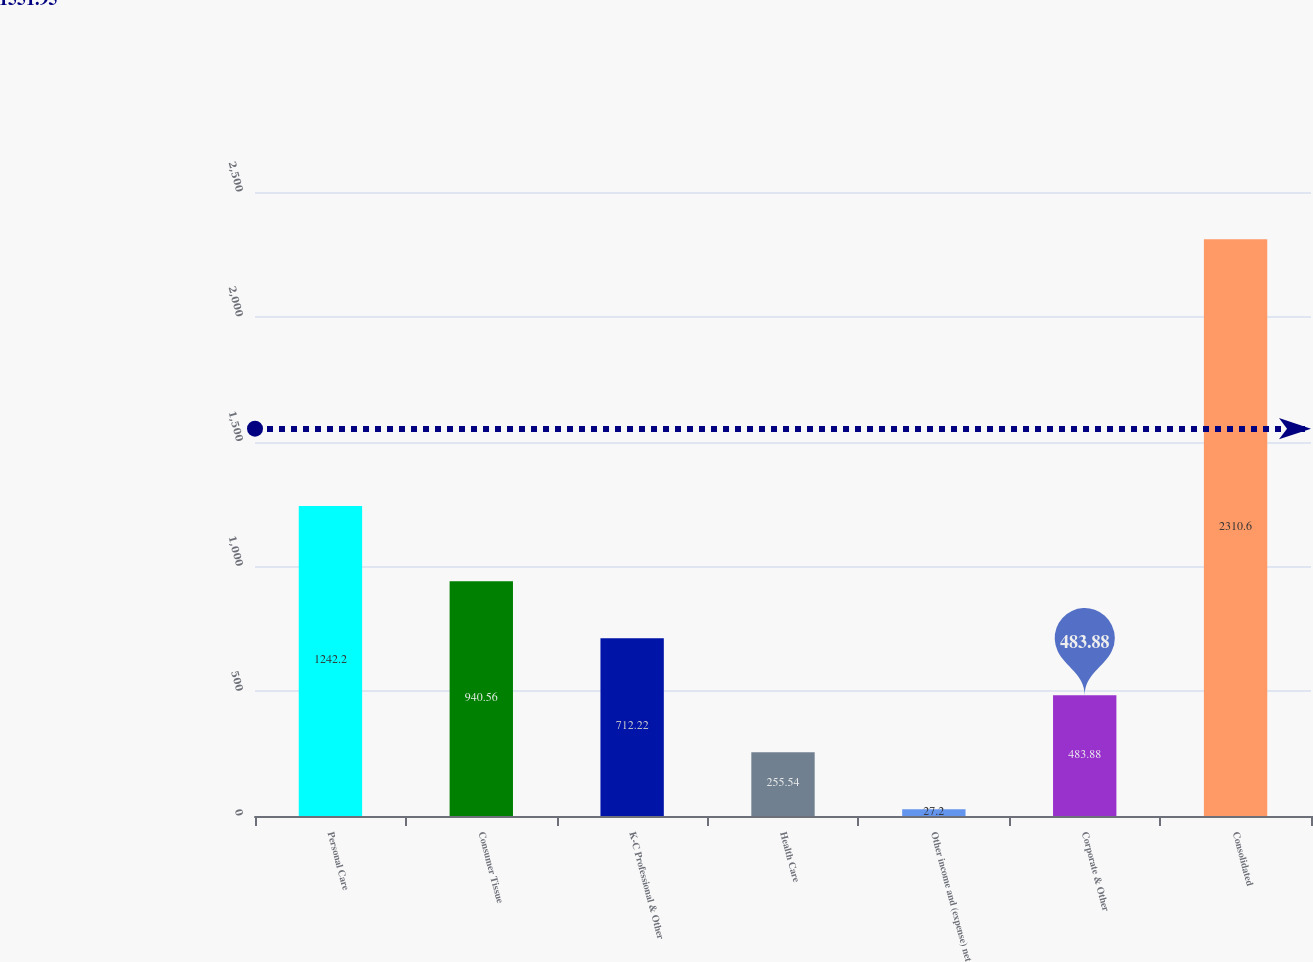Convert chart. <chart><loc_0><loc_0><loc_500><loc_500><bar_chart><fcel>Personal Care<fcel>Consumer Tissue<fcel>K-C Professional & Other<fcel>Health Care<fcel>Other income and (expense) net<fcel>Corporate & Other<fcel>Consolidated<nl><fcel>1242.2<fcel>940.56<fcel>712.22<fcel>255.54<fcel>27.2<fcel>483.88<fcel>2310.6<nl></chart> 